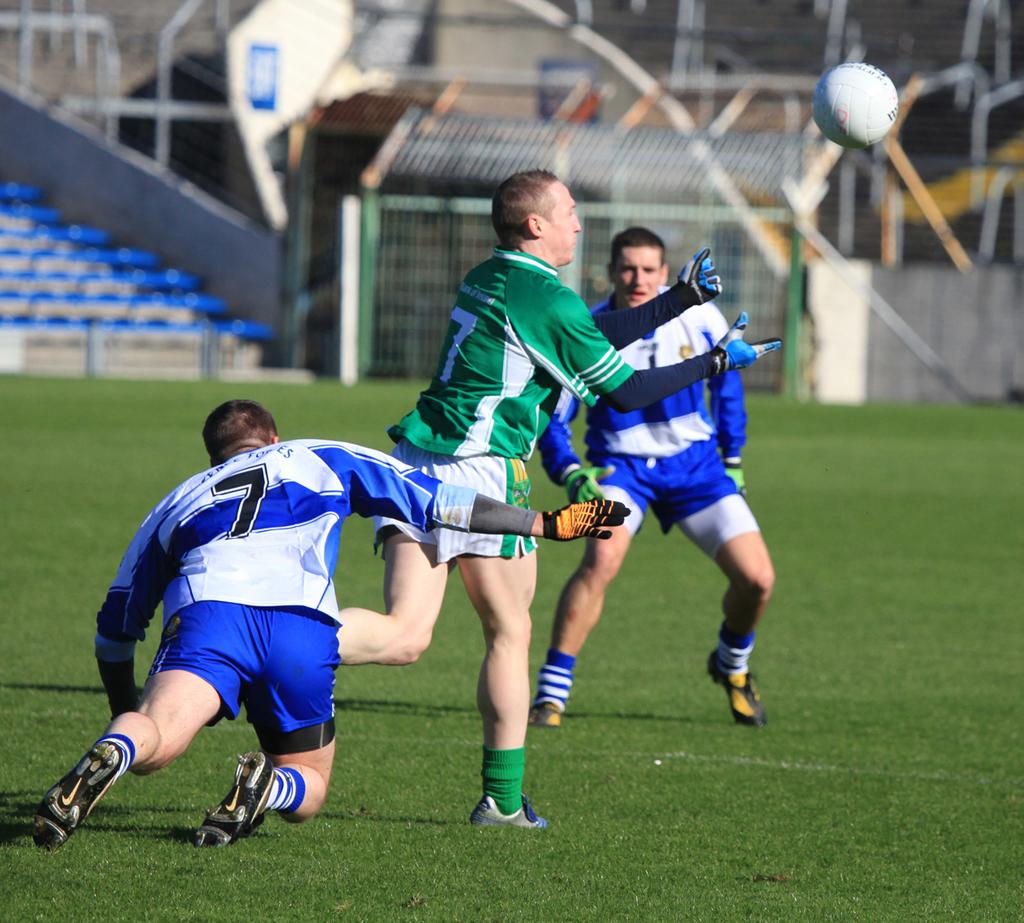Provide a one-sentence caption for the provided image. Three soccer players are playing and two of them are wearing number 7. 